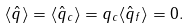Convert formula to latex. <formula><loc_0><loc_0><loc_500><loc_500>\langle \hat { q } \rangle = \langle \hat { q } _ { c } \rangle = q _ { c } \langle \hat { q } _ { f } \rangle = 0 .</formula> 